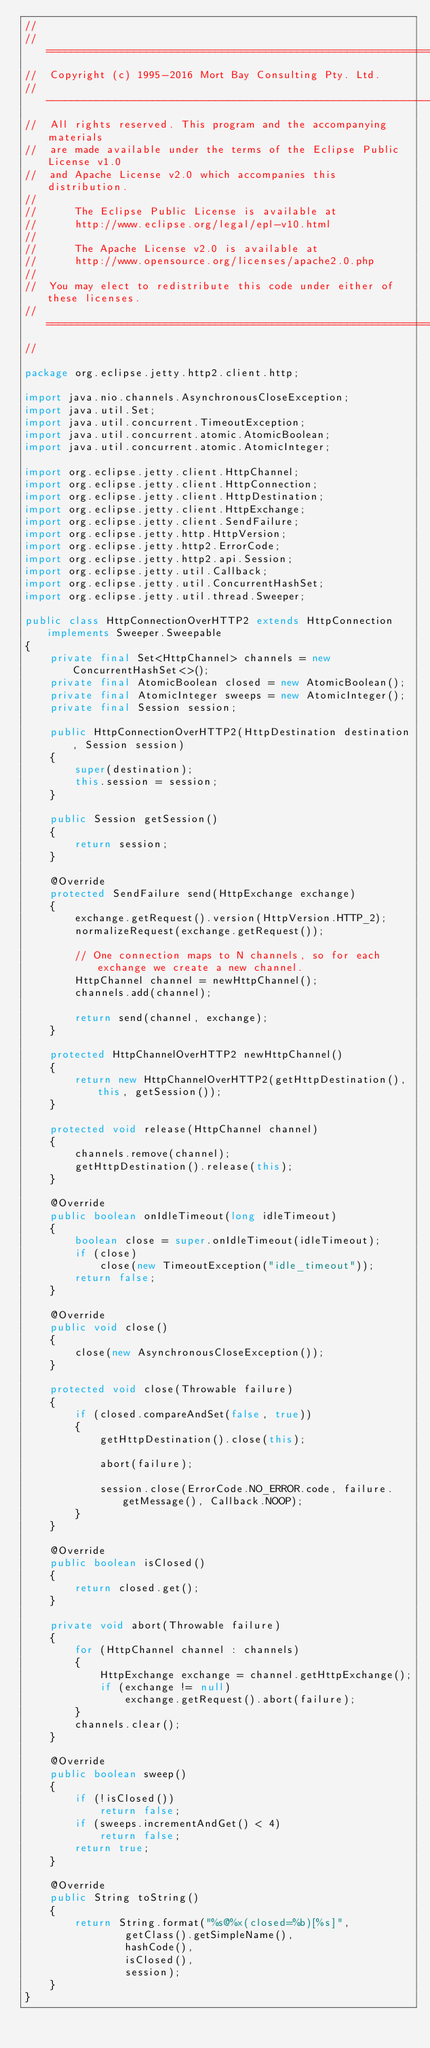<code> <loc_0><loc_0><loc_500><loc_500><_Java_>//
//  ========================================================================
//  Copyright (c) 1995-2016 Mort Bay Consulting Pty. Ltd.
//  ------------------------------------------------------------------------
//  All rights reserved. This program and the accompanying materials
//  are made available under the terms of the Eclipse Public License v1.0
//  and Apache License v2.0 which accompanies this distribution.
//
//      The Eclipse Public License is available at
//      http://www.eclipse.org/legal/epl-v10.html
//
//      The Apache License v2.0 is available at
//      http://www.opensource.org/licenses/apache2.0.php
//
//  You may elect to redistribute this code under either of these licenses.
//  ========================================================================
//

package org.eclipse.jetty.http2.client.http;

import java.nio.channels.AsynchronousCloseException;
import java.util.Set;
import java.util.concurrent.TimeoutException;
import java.util.concurrent.atomic.AtomicBoolean;
import java.util.concurrent.atomic.AtomicInteger;

import org.eclipse.jetty.client.HttpChannel;
import org.eclipse.jetty.client.HttpConnection;
import org.eclipse.jetty.client.HttpDestination;
import org.eclipse.jetty.client.HttpExchange;
import org.eclipse.jetty.client.SendFailure;
import org.eclipse.jetty.http.HttpVersion;
import org.eclipse.jetty.http2.ErrorCode;
import org.eclipse.jetty.http2.api.Session;
import org.eclipse.jetty.util.Callback;
import org.eclipse.jetty.util.ConcurrentHashSet;
import org.eclipse.jetty.util.thread.Sweeper;

public class HttpConnectionOverHTTP2 extends HttpConnection implements Sweeper.Sweepable
{
    private final Set<HttpChannel> channels = new ConcurrentHashSet<>();
    private final AtomicBoolean closed = new AtomicBoolean();
    private final AtomicInteger sweeps = new AtomicInteger();
    private final Session session;

    public HttpConnectionOverHTTP2(HttpDestination destination, Session session)
    {
        super(destination);
        this.session = session;
    }

    public Session getSession()
    {
        return session;
    }

    @Override
    protected SendFailure send(HttpExchange exchange)
    {
        exchange.getRequest().version(HttpVersion.HTTP_2);
        normalizeRequest(exchange.getRequest());

        // One connection maps to N channels, so for each exchange we create a new channel.
        HttpChannel channel = newHttpChannel();
        channels.add(channel);

        return send(channel, exchange);
    }

    protected HttpChannelOverHTTP2 newHttpChannel()
    {
        return new HttpChannelOverHTTP2(getHttpDestination(), this, getSession());
    }

    protected void release(HttpChannel channel)
    {
        channels.remove(channel);
        getHttpDestination().release(this);
    }

    @Override
    public boolean onIdleTimeout(long idleTimeout)
    {
        boolean close = super.onIdleTimeout(idleTimeout);
        if (close)
            close(new TimeoutException("idle_timeout"));
        return false;
    }

    @Override
    public void close()
    {
        close(new AsynchronousCloseException());
    }

    protected void close(Throwable failure)
    {
        if (closed.compareAndSet(false, true))
        {
            getHttpDestination().close(this);

            abort(failure);

            session.close(ErrorCode.NO_ERROR.code, failure.getMessage(), Callback.NOOP);
        }
    }

    @Override
    public boolean isClosed()
    {
        return closed.get();
    }

    private void abort(Throwable failure)
    {
        for (HttpChannel channel : channels)
        {
            HttpExchange exchange = channel.getHttpExchange();
            if (exchange != null)
                exchange.getRequest().abort(failure);
        }
        channels.clear();
    }

    @Override
    public boolean sweep()
    {
        if (!isClosed())
            return false;
        if (sweeps.incrementAndGet() < 4)
            return false;
        return true;
    }

    @Override
    public String toString()
    {
        return String.format("%s@%x(closed=%b)[%s]",
                getClass().getSimpleName(),
                hashCode(),
                isClosed(),
                session);
    }
}
</code> 